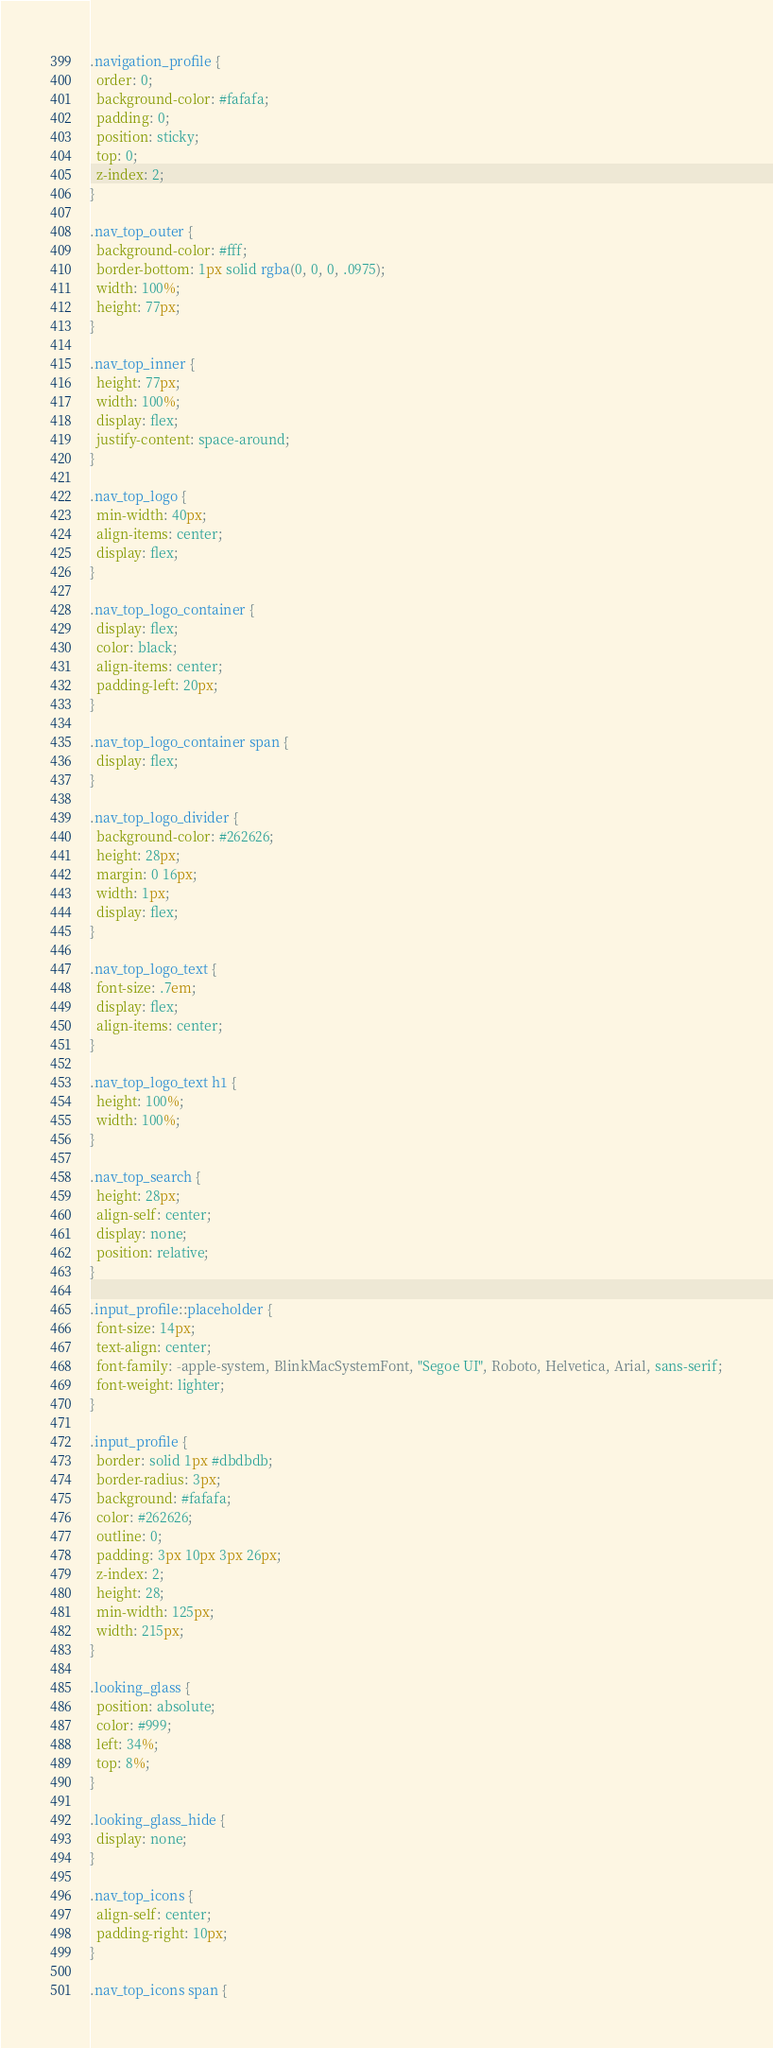Convert code to text. <code><loc_0><loc_0><loc_500><loc_500><_CSS_>.navigation_profile {
  order: 0;
  background-color: #fafafa;
  padding: 0;
  position: sticky;
  top: 0;
  z-index: 2;
}

.nav_top_outer {
  background-color: #fff;
  border-bottom: 1px solid rgba(0, 0, 0, .0975);
  width: 100%;
  height: 77px;
}

.nav_top_inner {
  height: 77px;
  width: 100%;
  display: flex;
  justify-content: space-around;
}

.nav_top_logo {
  min-width: 40px;
  align-items: center;
  display: flex;
}

.nav_top_logo_container {
  display: flex;
  color: black;
  align-items: center;
  padding-left: 20px;
}

.nav_top_logo_container span {
  display: flex;
}

.nav_top_logo_divider {
  background-color: #262626;
  height: 28px;
  margin: 0 16px;
  width: 1px;
  display: flex;
}

.nav_top_logo_text {
  font-size: .7em;
  display: flex;
  align-items: center;
}

.nav_top_logo_text h1 {
  height: 100%;
  width: 100%;
}

.nav_top_search {
  height: 28px;
  align-self: center;
  display: none;
  position: relative;
}

.input_profile::placeholder {
  font-size: 14px;
  text-align: center;
  font-family: -apple-system, BlinkMacSystemFont, "Segoe UI", Roboto, Helvetica, Arial, sans-serif;
  font-weight: lighter;
}

.input_profile {
  border: solid 1px #dbdbdb;
  border-radius: 3px;
  background: #fafafa;
  color: #262626;
  outline: 0;
  padding: 3px 10px 3px 26px;
  z-index: 2;
  height: 28;
  min-width: 125px;
  width: 215px;
}

.looking_glass {
  position: absolute;
  color: #999;
  left: 34%;
  top: 8%;
}

.looking_glass_hide {
  display: none;
}

.nav_top_icons {
  align-self: center;
  padding-right: 10px;
}

.nav_top_icons span {</code> 